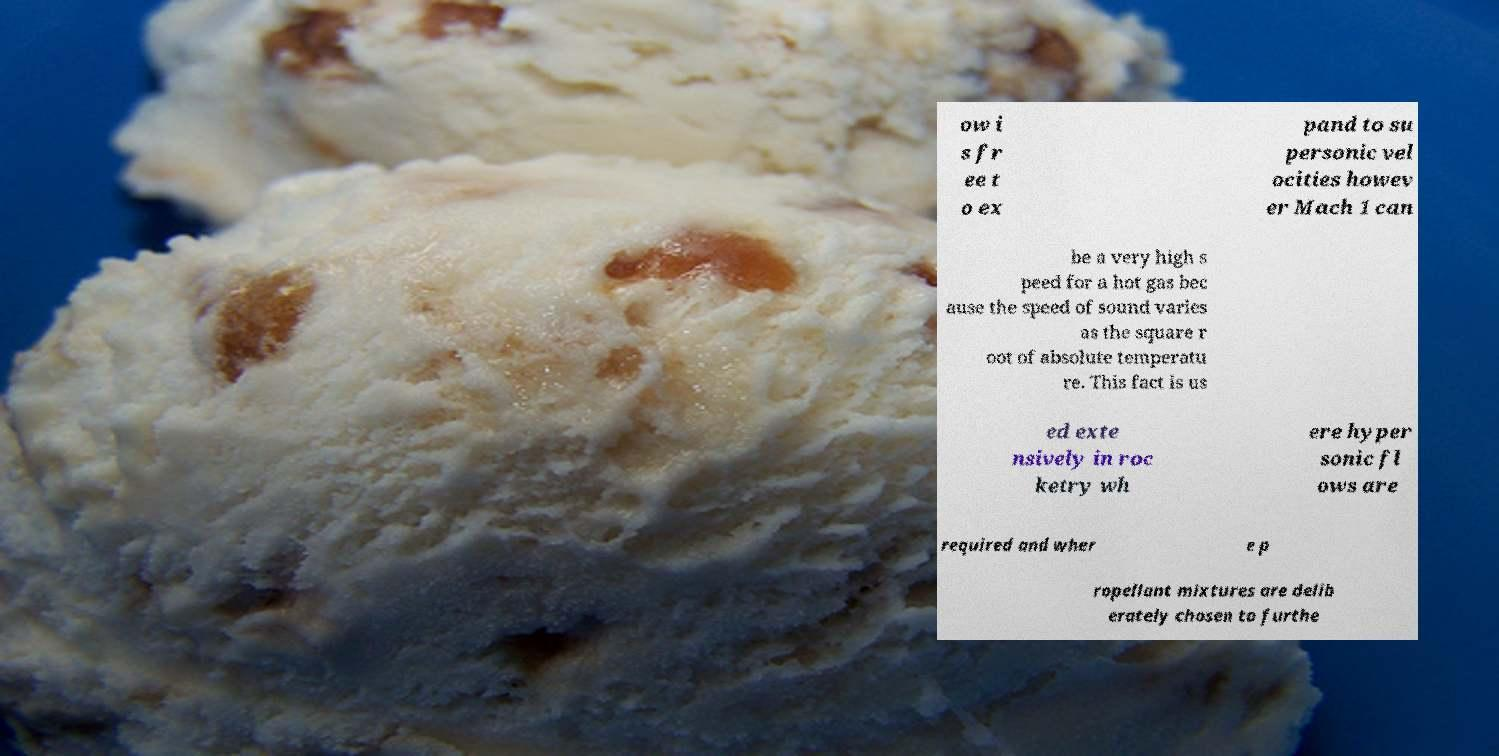What messages or text are displayed in this image? I need them in a readable, typed format. ow i s fr ee t o ex pand to su personic vel ocities howev er Mach 1 can be a very high s peed for a hot gas bec ause the speed of sound varies as the square r oot of absolute temperatu re. This fact is us ed exte nsively in roc ketry wh ere hyper sonic fl ows are required and wher e p ropellant mixtures are delib erately chosen to furthe 